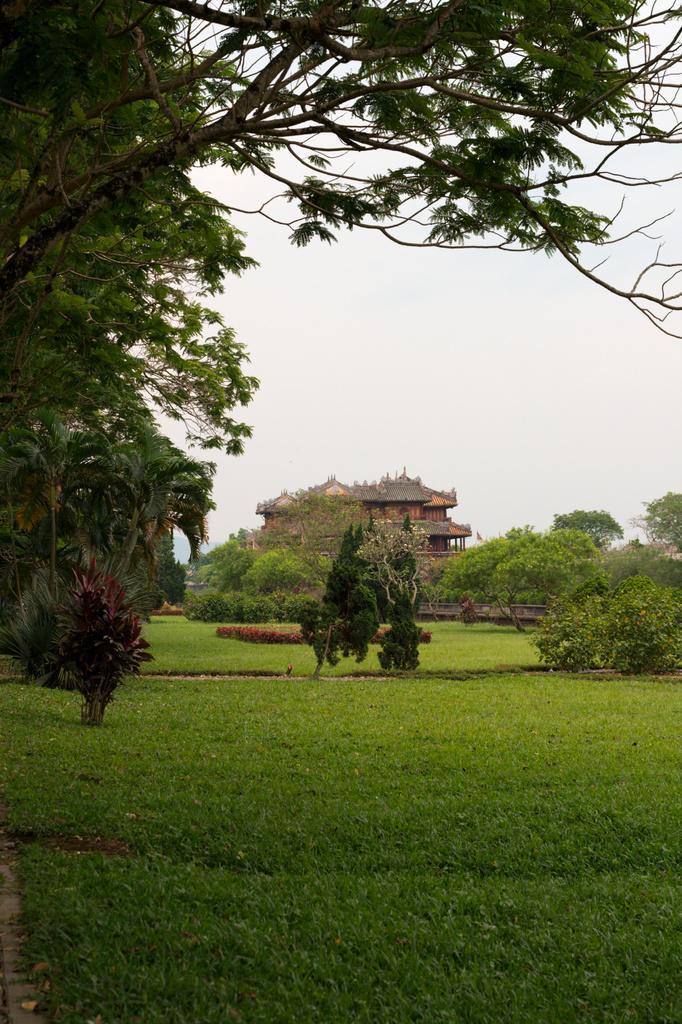How would you summarize this image in a sentence or two? In the foreground of this image, there is the grassland, few plants, trees, a building and the sky. 